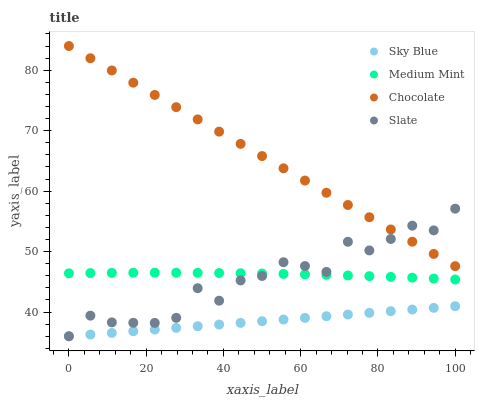Does Sky Blue have the minimum area under the curve?
Answer yes or no. Yes. Does Chocolate have the maximum area under the curve?
Answer yes or no. Yes. Does Slate have the minimum area under the curve?
Answer yes or no. No. Does Slate have the maximum area under the curve?
Answer yes or no. No. Is Sky Blue the smoothest?
Answer yes or no. Yes. Is Slate the roughest?
Answer yes or no. Yes. Is Slate the smoothest?
Answer yes or no. No. Is Sky Blue the roughest?
Answer yes or no. No. Does Sky Blue have the lowest value?
Answer yes or no. Yes. Does Chocolate have the lowest value?
Answer yes or no. No. Does Chocolate have the highest value?
Answer yes or no. Yes. Does Slate have the highest value?
Answer yes or no. No. Is Sky Blue less than Chocolate?
Answer yes or no. Yes. Is Medium Mint greater than Sky Blue?
Answer yes or no. Yes. Does Slate intersect Sky Blue?
Answer yes or no. Yes. Is Slate less than Sky Blue?
Answer yes or no. No. Is Slate greater than Sky Blue?
Answer yes or no. No. Does Sky Blue intersect Chocolate?
Answer yes or no. No. 